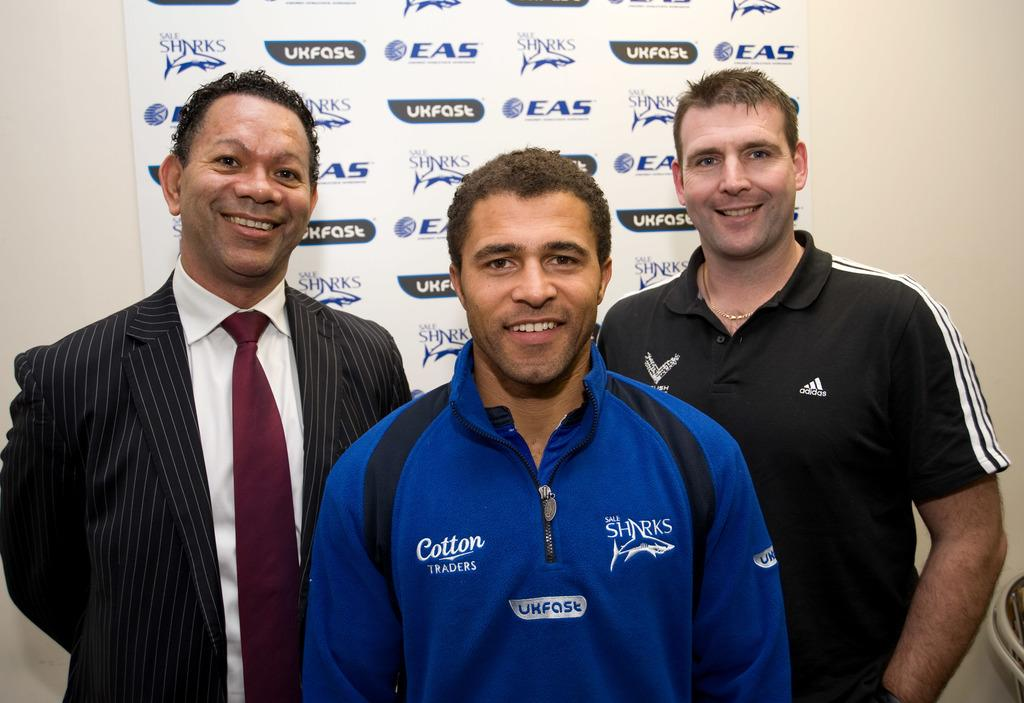Provide a one-sentence caption for the provided image. 3 men smiling for a picture, the Sale Sharks logo is displayed in the back and on a man's shirt. 